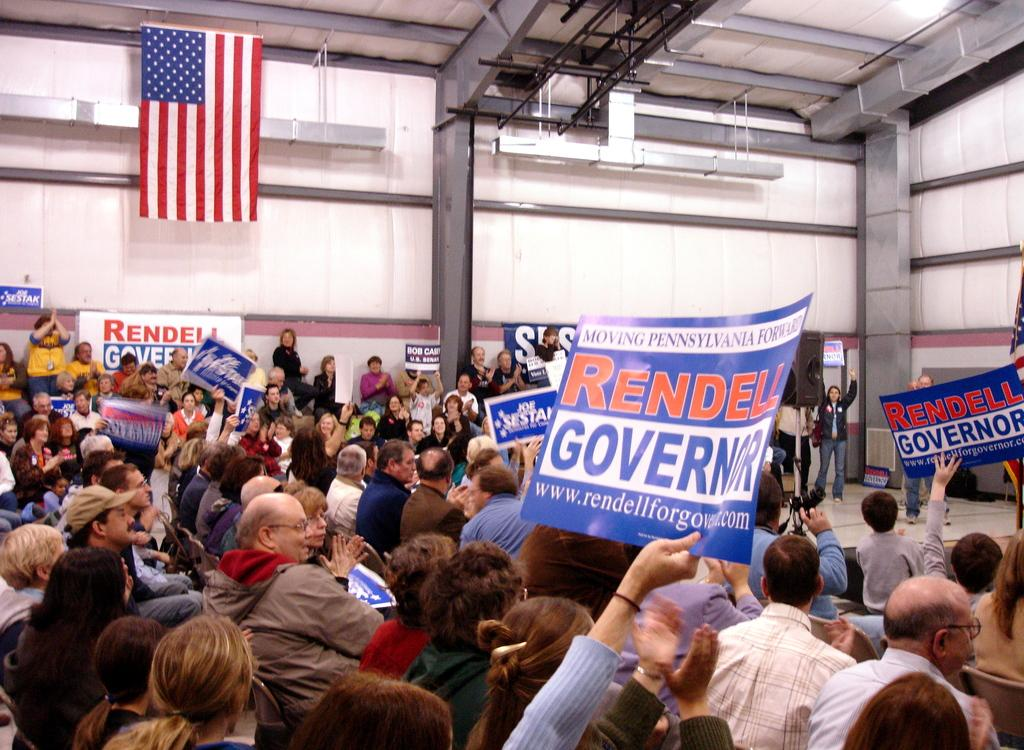How many people are in the image? There is a group of people in the image, but the exact number is not specified. What can be seen on the walls in the image? In the background of the image, there are walls, but the conversation does not mention any specific details about what is on the walls. What is the purpose of the camera in the image? The presence of a camera in the image suggests that someone might be taking photos or recording a video, but the specific purpose is not known. What type of objects are present in the background of the image? In the background of the image, there are some objects, but the conversation does not specify what kind of objects they are. Can you see any rabbits or lizards in the image? No, there are no rabbits or lizards present in the image. Is the image taken on a slope? The facts do not mention any information about the terrain or the angle of the image, so it is not possible to determine if the image is taken on a slope. 